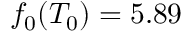Convert formula to latex. <formula><loc_0><loc_0><loc_500><loc_500>f _ { 0 } ( T _ { 0 } ) = 5 . 8 9</formula> 